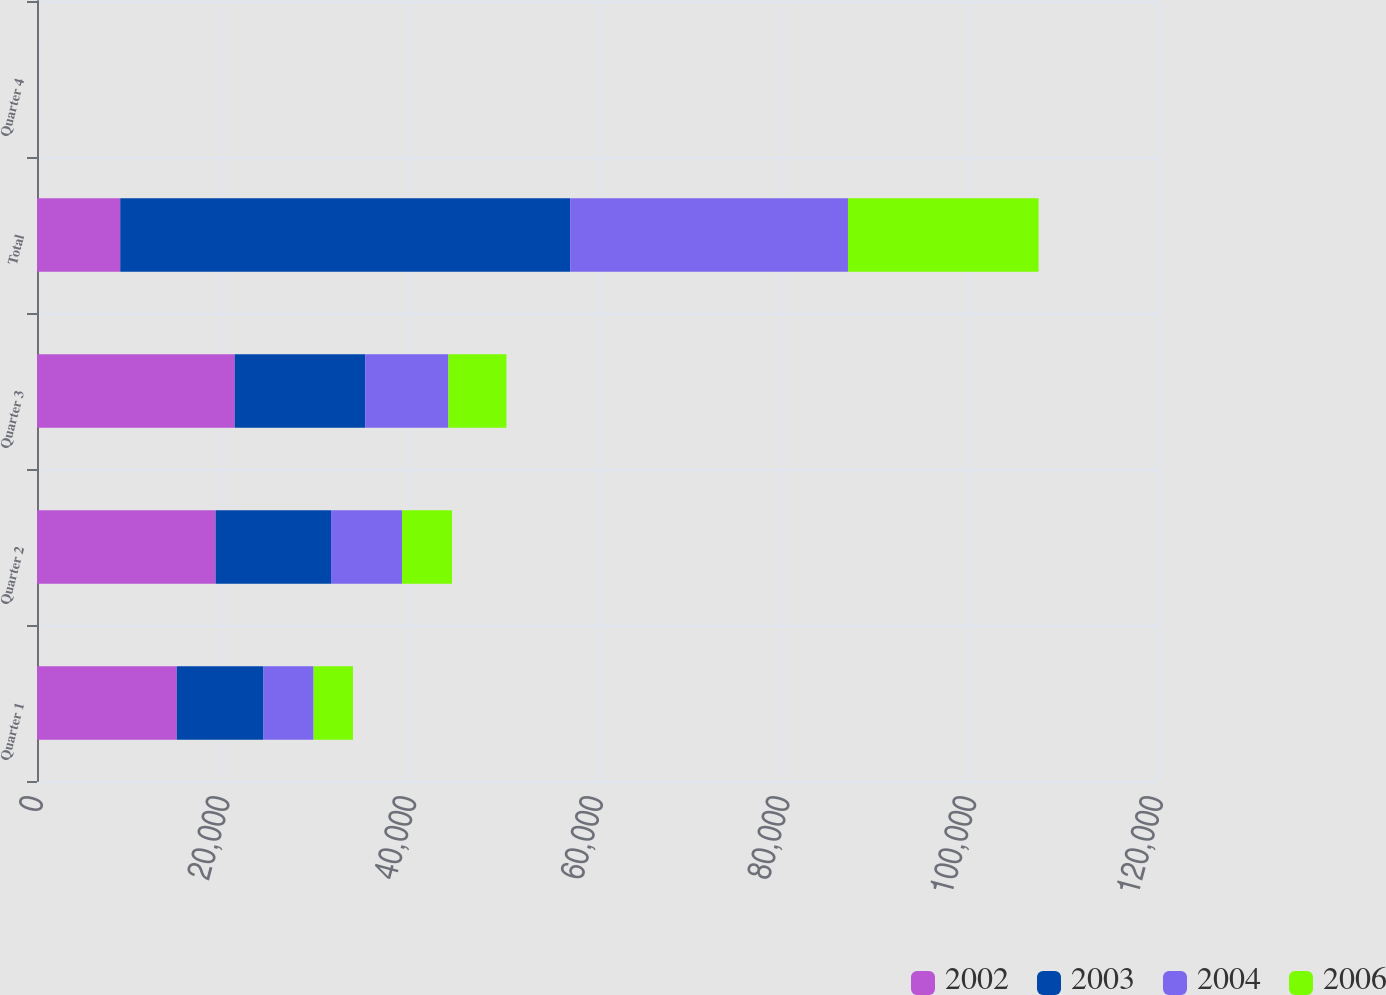<chart> <loc_0><loc_0><loc_500><loc_500><stacked_bar_chart><ecel><fcel>Quarter 1<fcel>Quarter 2<fcel>Quarter 3<fcel>Total<fcel>Quarter 4<nl><fcel>2002<fcel>14974<fcel>19136<fcel>21176<fcel>8916<fcel>8.67<nl><fcel>2003<fcel>9295<fcel>12368<fcel>13983<fcel>48214<fcel>7.8<nl><fcel>2004<fcel>5368<fcel>7605<fcel>8916<fcel>29760<fcel>6.4<nl><fcel>2006<fcel>4219<fcel>5356<fcel>6221<fcel>20421<fcel>5.74<nl></chart> 